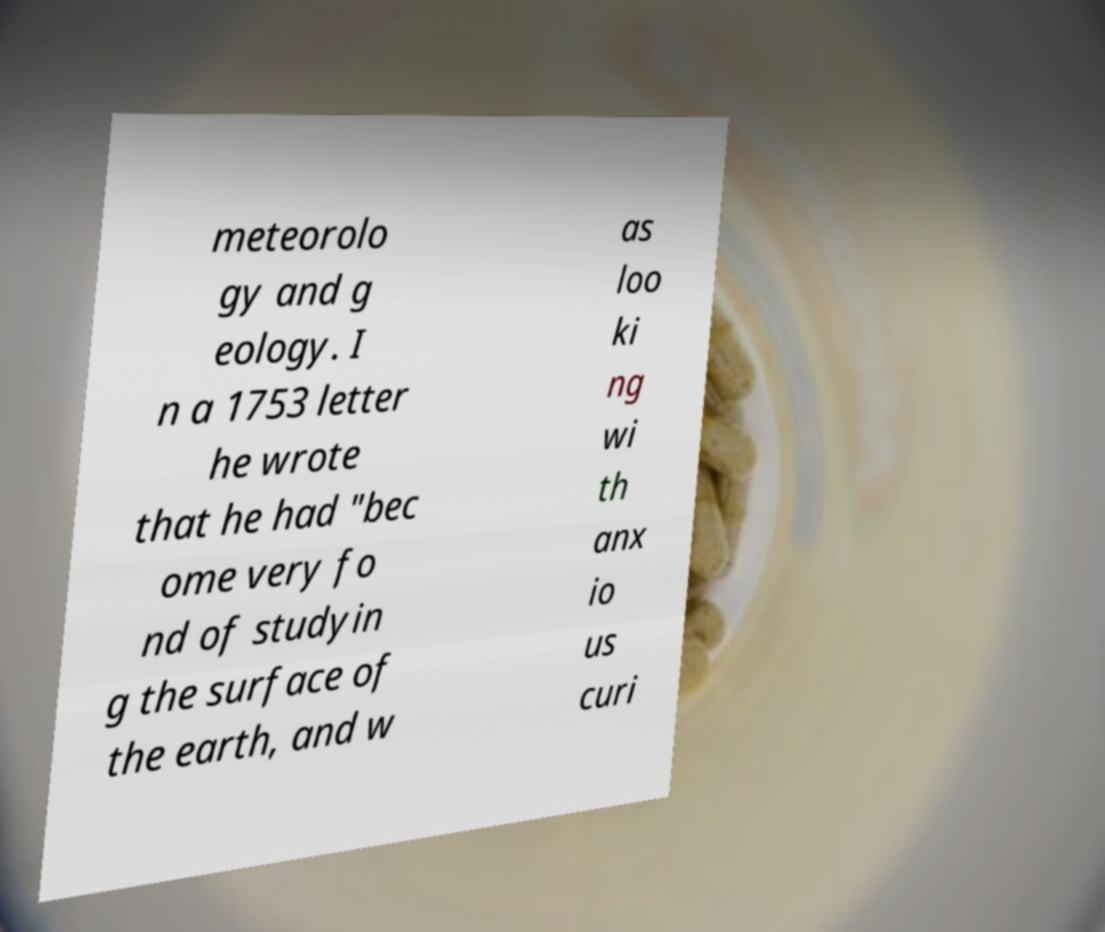For documentation purposes, I need the text within this image transcribed. Could you provide that? meteorolo gy and g eology. I n a 1753 letter he wrote that he had "bec ome very fo nd of studyin g the surface of the earth, and w as loo ki ng wi th anx io us curi 